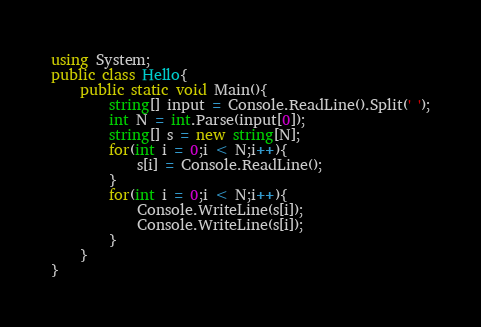Convert code to text. <code><loc_0><loc_0><loc_500><loc_500><_C#_>using System;
public class Hello{
    public static void Main(){
        string[] input = Console.ReadLine().Split(' ');
        int N = int.Parse(input[0]);
        string[] s = new string[N];
        for(int i = 0;i < N;i++){
            s[i] = Console.ReadLine();
        }
        for(int i = 0;i < N;i++){
            Console.WriteLine(s[i]);
            Console.WriteLine(s[i]);
        }
    }
}
</code> 